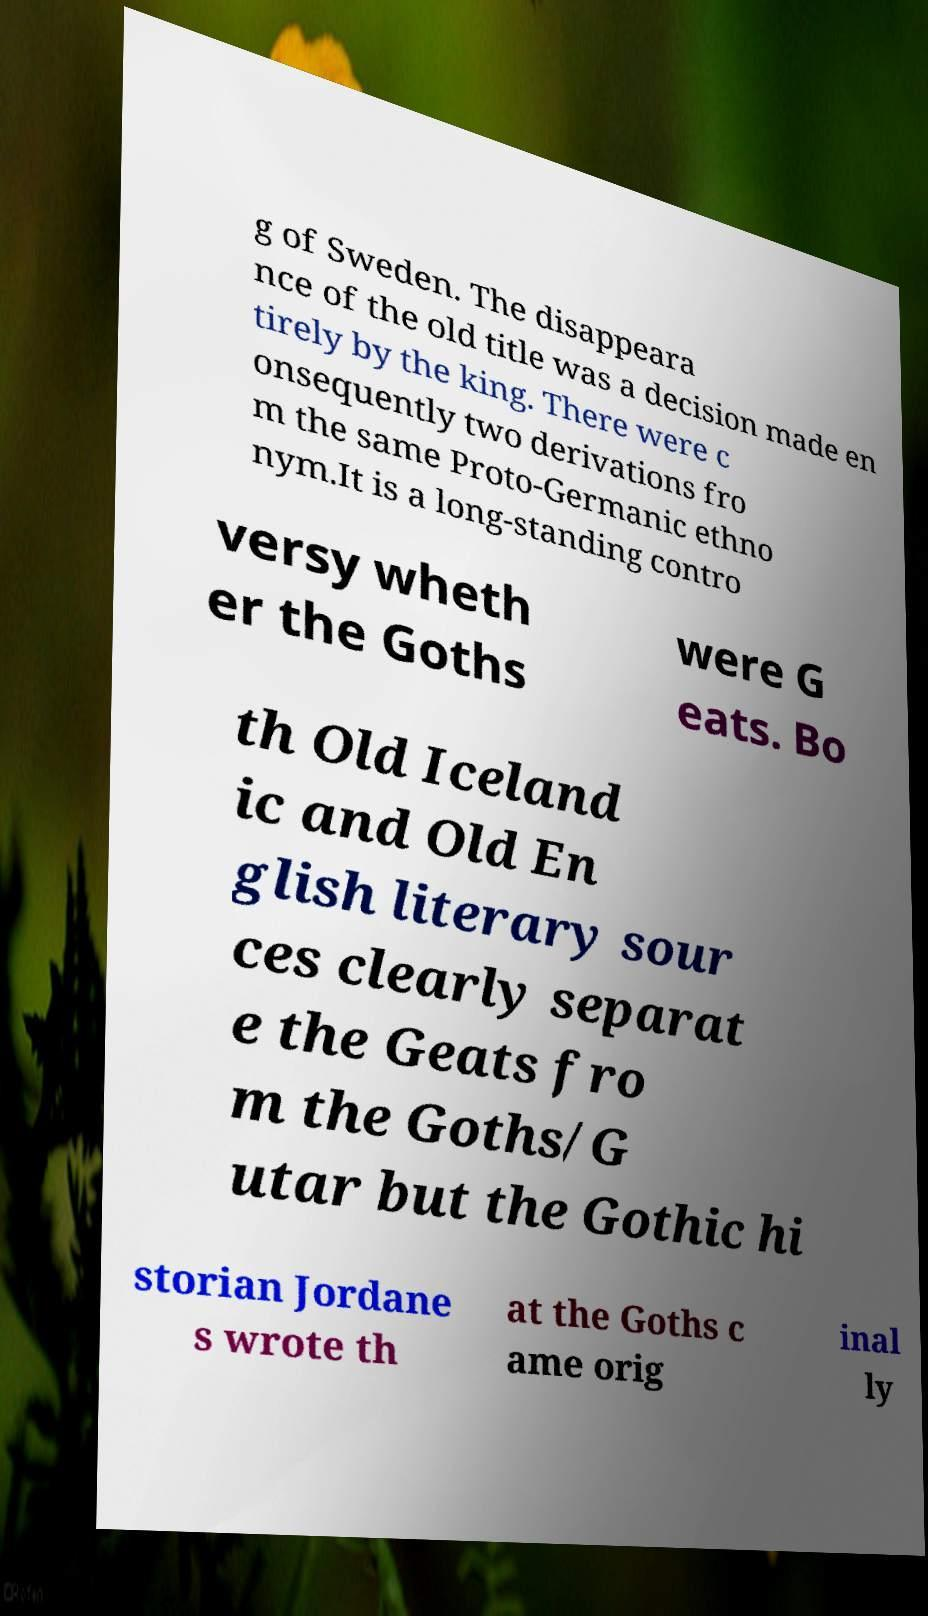Can you accurately transcribe the text from the provided image for me? g of Sweden. The disappeara nce of the old title was a decision made en tirely by the king. There were c onsequently two derivations fro m the same Proto-Germanic ethno nym.It is a long-standing contro versy wheth er the Goths were G eats. Bo th Old Iceland ic and Old En glish literary sour ces clearly separat e the Geats fro m the Goths/G utar but the Gothic hi storian Jordane s wrote th at the Goths c ame orig inal ly 